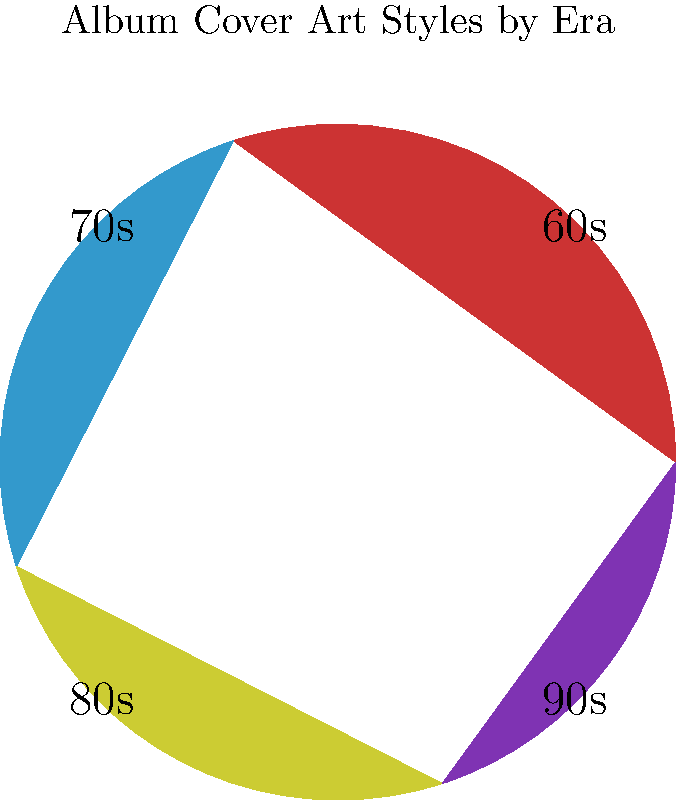Based on the pie chart representing album cover art styles by era, which decade had the most significant influence on Led Zeppelin's iconic album artwork? To answer this question, let's analyze the information provided in the pie chart:

1. The pie chart shows the distribution of album cover art styles across four decades: 60s, 70s, 80s, and 90s.

2. Led Zeppelin was most active and influential during the 1970s, releasing their iconic albums during this period.

3. Looking at the pie chart, we can see that the largest slice represents the 60s (red), followed by two equal slices for the 70s (blue) and 80s (yellow), and the smallest slice for the 90s (purple).

4. However, as an aspiring musician inspired by Led Zeppelin, you should know that their most iconic album covers, such as "Led Zeppelin IV" (1971) and "Houses of the Holy" (1973), were created in the 1970s.

5. The 70s slice in the pie chart is significant, representing 25% of the total, which aligns with Led Zeppelin's peak period and their most memorable album artwork.

6. While the 60s slice is slightly larger, Led Zeppelin's formation in 1968 means their most iconic work and album covers came after this period.

Therefore, despite the 60s having a larger slice in the pie chart, the 70s had the most significant influence on Led Zeppelin's iconic album artwork.
Answer: 1970s 